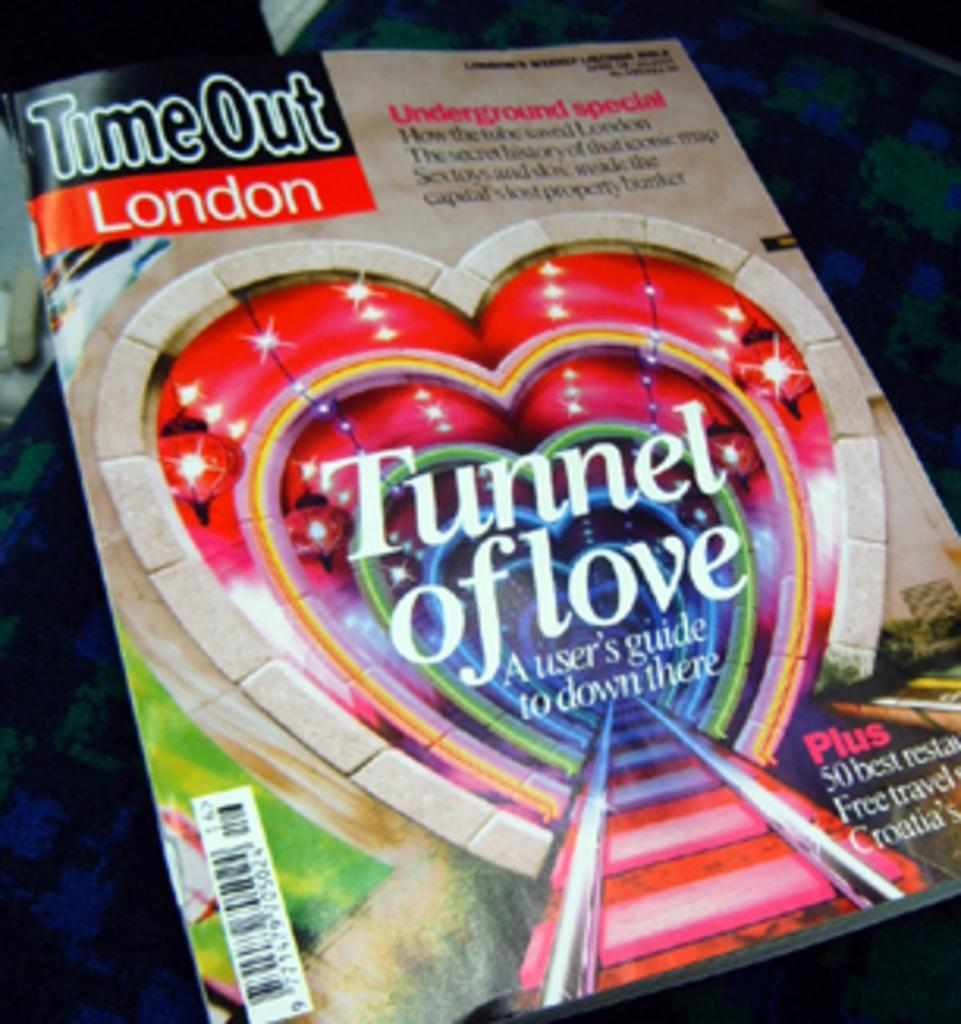<image>
Offer a succinct explanation of the picture presented. TimeOut London Magazine with a feature called Tunnel Of Love 